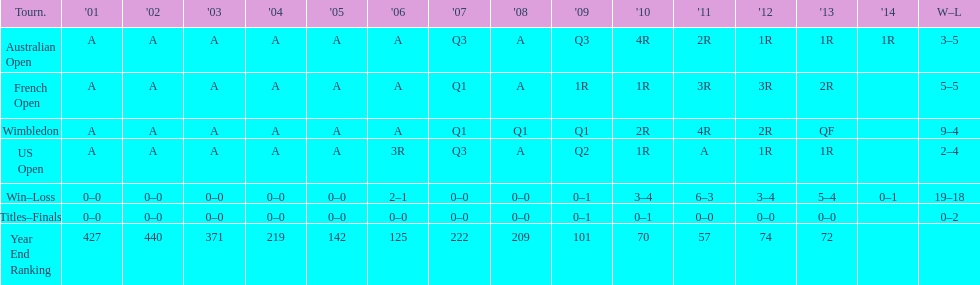For this player, what is the variation in the number of wins at wimbledon and the us open? 7. Would you be able to parse every entry in this table? {'header': ['Tourn.', "'01", "'02", "'03", "'04", "'05", "'06", "'07", "'08", "'09", "'10", "'11", "'12", "'13", "'14", 'W–L'], 'rows': [['Australian Open', 'A', 'A', 'A', 'A', 'A', 'A', 'Q3', 'A', 'Q3', '4R', '2R', '1R', '1R', '1R', '3–5'], ['French Open', 'A', 'A', 'A', 'A', 'A', 'A', 'Q1', 'A', '1R', '1R', '3R', '3R', '2R', '', '5–5'], ['Wimbledon', 'A', 'A', 'A', 'A', 'A', 'A', 'Q1', 'Q1', 'Q1', '2R', '4R', '2R', 'QF', '', '9–4'], ['US Open', 'A', 'A', 'A', 'A', 'A', '3R', 'Q3', 'A', 'Q2', '1R', 'A', '1R', '1R', '', '2–4'], ['Win–Loss', '0–0', '0–0', '0–0', '0–0', '0–0', '2–1', '0–0', '0–0', '0–1', '3–4', '6–3', '3–4', '5–4', '0–1', '19–18'], ['Titles–Finals', '0–0', '0–0', '0–0', '0–0', '0–0', '0–0', '0–0', '0–0', '0–1', '0–1', '0–0', '0–0', '0–0', '', '0–2'], ['Year End Ranking', '427', '440', '371', '219', '142', '125', '222', '209', '101', '70', '57', '74', '72', '', '']]} 